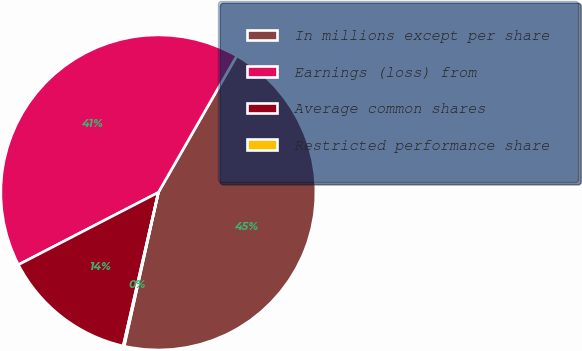<chart> <loc_0><loc_0><loc_500><loc_500><pie_chart><fcel>In millions except per share<fcel>Earnings (loss) from<fcel>Average common shares<fcel>Restricted performance share<nl><fcel>45.19%<fcel>40.88%<fcel>13.83%<fcel>0.1%<nl></chart> 